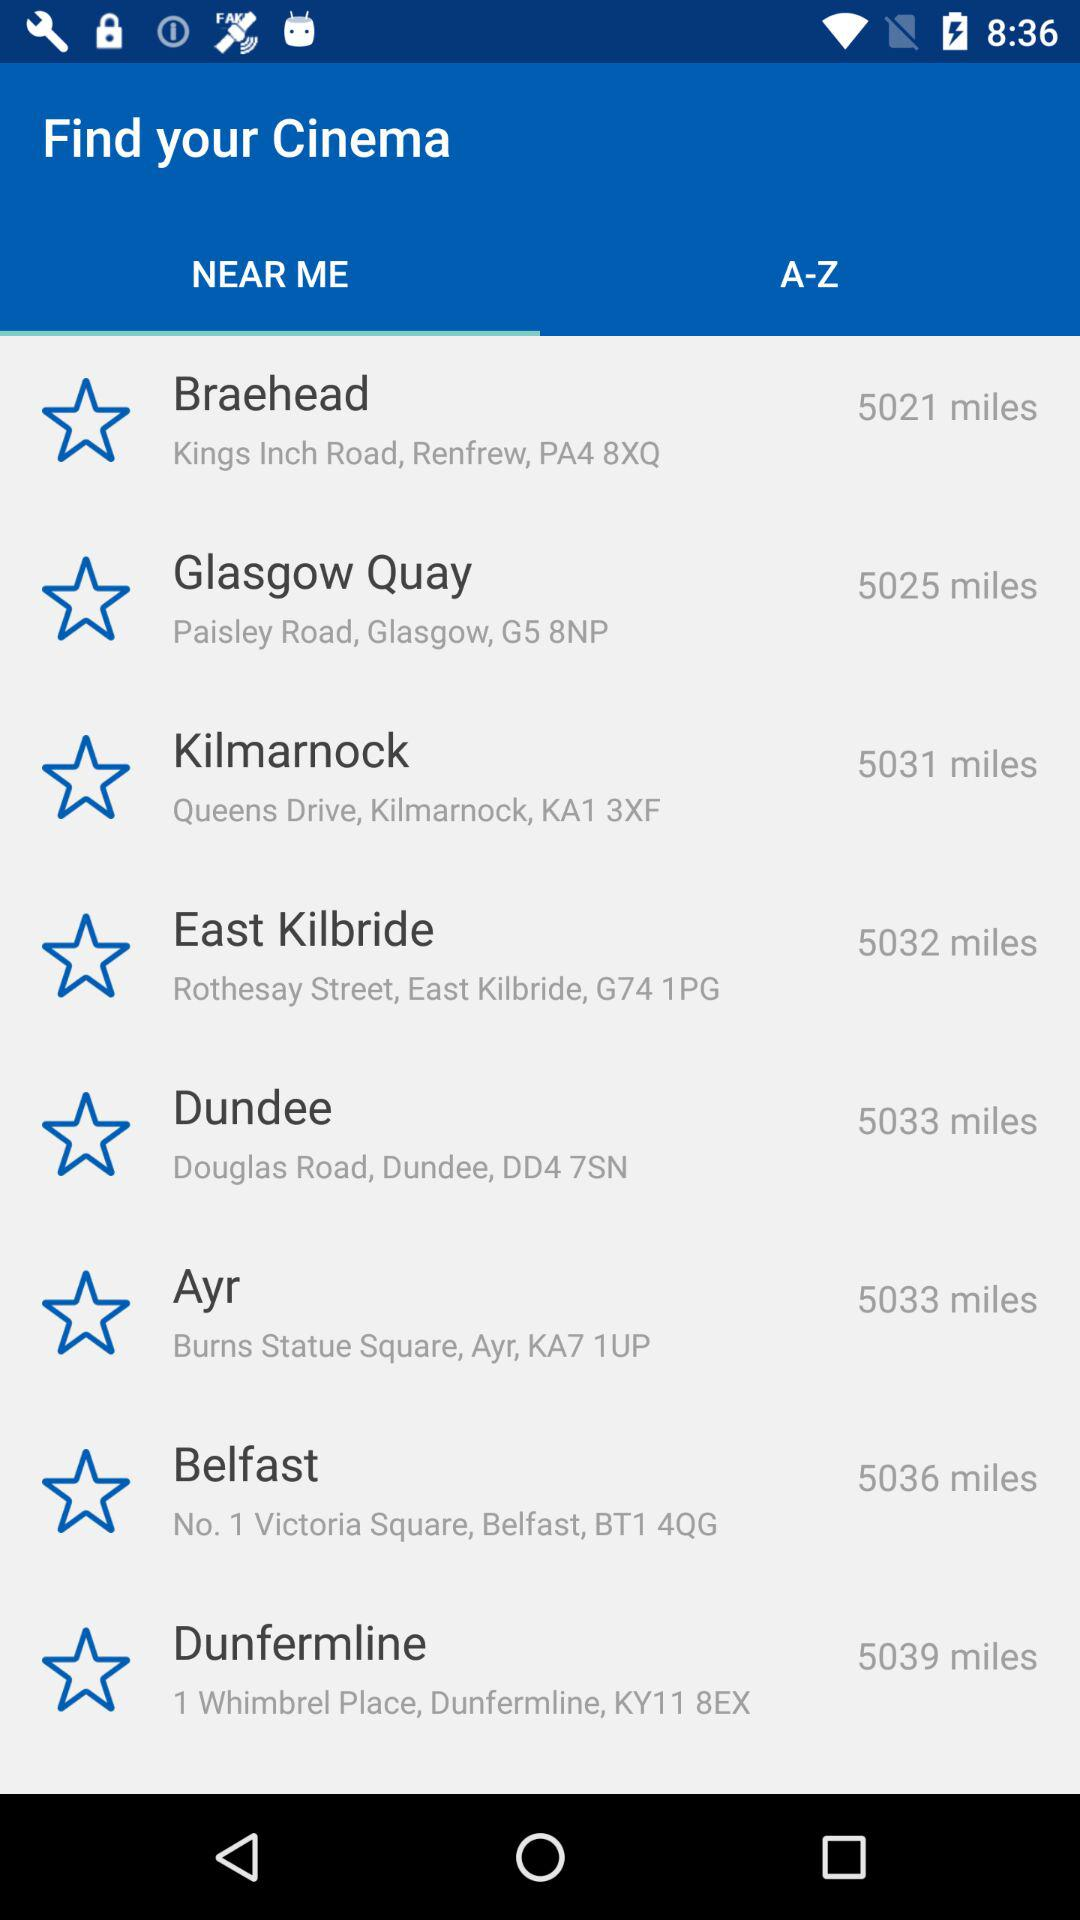What is the distance between Glasgow Quay and my location? The distance between Glasgow Quay and your location is 5025 miles. 